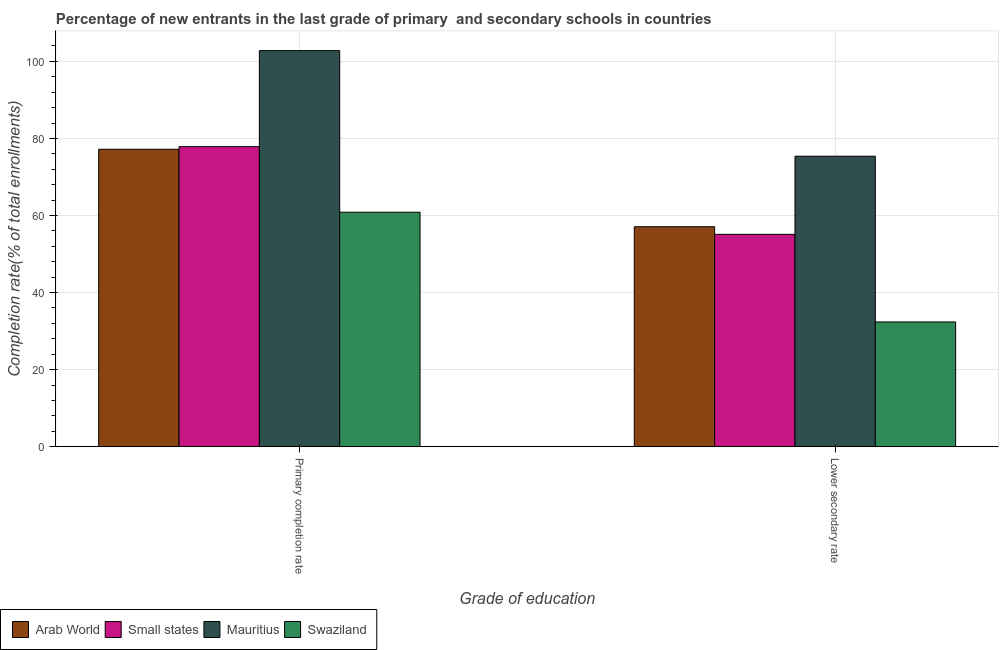How many different coloured bars are there?
Provide a short and direct response. 4. How many groups of bars are there?
Your answer should be very brief. 2. How many bars are there on the 2nd tick from the left?
Give a very brief answer. 4. What is the label of the 1st group of bars from the left?
Ensure brevity in your answer.  Primary completion rate. What is the completion rate in primary schools in Swaziland?
Give a very brief answer. 60.86. Across all countries, what is the maximum completion rate in primary schools?
Your answer should be very brief. 102.79. Across all countries, what is the minimum completion rate in primary schools?
Give a very brief answer. 60.86. In which country was the completion rate in primary schools maximum?
Your answer should be compact. Mauritius. In which country was the completion rate in primary schools minimum?
Provide a short and direct response. Swaziland. What is the total completion rate in secondary schools in the graph?
Ensure brevity in your answer.  219.97. What is the difference between the completion rate in primary schools in Mauritius and that in Small states?
Your response must be concise. 24.92. What is the difference between the completion rate in primary schools in Swaziland and the completion rate in secondary schools in Small states?
Ensure brevity in your answer.  5.75. What is the average completion rate in primary schools per country?
Provide a succinct answer. 79.68. What is the difference between the completion rate in secondary schools and completion rate in primary schools in Swaziland?
Make the answer very short. -28.48. In how many countries, is the completion rate in primary schools greater than 72 %?
Provide a succinct answer. 3. What is the ratio of the completion rate in secondary schools in Swaziland to that in Arab World?
Your response must be concise. 0.57. In how many countries, is the completion rate in secondary schools greater than the average completion rate in secondary schools taken over all countries?
Your answer should be very brief. 3. What does the 3rd bar from the left in Lower secondary rate represents?
Your response must be concise. Mauritius. What does the 2nd bar from the right in Lower secondary rate represents?
Provide a short and direct response. Mauritius. How many countries are there in the graph?
Offer a very short reply. 4. What is the difference between two consecutive major ticks on the Y-axis?
Your answer should be compact. 20. Are the values on the major ticks of Y-axis written in scientific E-notation?
Your answer should be compact. No. Does the graph contain grids?
Offer a terse response. Yes. Where does the legend appear in the graph?
Your response must be concise. Bottom left. What is the title of the graph?
Ensure brevity in your answer.  Percentage of new entrants in the last grade of primary  and secondary schools in countries. What is the label or title of the X-axis?
Offer a very short reply. Grade of education. What is the label or title of the Y-axis?
Your response must be concise. Completion rate(% of total enrollments). What is the Completion rate(% of total enrollments) in Arab World in Primary completion rate?
Provide a short and direct response. 77.19. What is the Completion rate(% of total enrollments) in Small states in Primary completion rate?
Your answer should be compact. 77.87. What is the Completion rate(% of total enrollments) of Mauritius in Primary completion rate?
Make the answer very short. 102.79. What is the Completion rate(% of total enrollments) in Swaziland in Primary completion rate?
Offer a very short reply. 60.86. What is the Completion rate(% of total enrollments) in Arab World in Lower secondary rate?
Give a very brief answer. 57.09. What is the Completion rate(% of total enrollments) in Small states in Lower secondary rate?
Provide a short and direct response. 55.11. What is the Completion rate(% of total enrollments) in Mauritius in Lower secondary rate?
Your answer should be very brief. 75.39. What is the Completion rate(% of total enrollments) in Swaziland in Lower secondary rate?
Make the answer very short. 32.38. Across all Grade of education, what is the maximum Completion rate(% of total enrollments) in Arab World?
Give a very brief answer. 77.19. Across all Grade of education, what is the maximum Completion rate(% of total enrollments) of Small states?
Provide a short and direct response. 77.87. Across all Grade of education, what is the maximum Completion rate(% of total enrollments) in Mauritius?
Offer a very short reply. 102.79. Across all Grade of education, what is the maximum Completion rate(% of total enrollments) of Swaziland?
Keep it short and to the point. 60.86. Across all Grade of education, what is the minimum Completion rate(% of total enrollments) in Arab World?
Provide a short and direct response. 57.09. Across all Grade of education, what is the minimum Completion rate(% of total enrollments) of Small states?
Your answer should be very brief. 55.11. Across all Grade of education, what is the minimum Completion rate(% of total enrollments) in Mauritius?
Give a very brief answer. 75.39. Across all Grade of education, what is the minimum Completion rate(% of total enrollments) in Swaziland?
Your answer should be very brief. 32.38. What is the total Completion rate(% of total enrollments) in Arab World in the graph?
Ensure brevity in your answer.  134.28. What is the total Completion rate(% of total enrollments) of Small states in the graph?
Your answer should be very brief. 132.99. What is the total Completion rate(% of total enrollments) of Mauritius in the graph?
Provide a short and direct response. 178.18. What is the total Completion rate(% of total enrollments) in Swaziland in the graph?
Your answer should be very brief. 93.24. What is the difference between the Completion rate(% of total enrollments) of Arab World in Primary completion rate and that in Lower secondary rate?
Provide a short and direct response. 20.11. What is the difference between the Completion rate(% of total enrollments) of Small states in Primary completion rate and that in Lower secondary rate?
Provide a short and direct response. 22.76. What is the difference between the Completion rate(% of total enrollments) of Mauritius in Primary completion rate and that in Lower secondary rate?
Provide a short and direct response. 27.4. What is the difference between the Completion rate(% of total enrollments) of Swaziland in Primary completion rate and that in Lower secondary rate?
Your response must be concise. 28.48. What is the difference between the Completion rate(% of total enrollments) of Arab World in Primary completion rate and the Completion rate(% of total enrollments) of Small states in Lower secondary rate?
Provide a succinct answer. 22.08. What is the difference between the Completion rate(% of total enrollments) of Arab World in Primary completion rate and the Completion rate(% of total enrollments) of Mauritius in Lower secondary rate?
Make the answer very short. 1.8. What is the difference between the Completion rate(% of total enrollments) of Arab World in Primary completion rate and the Completion rate(% of total enrollments) of Swaziland in Lower secondary rate?
Ensure brevity in your answer.  44.81. What is the difference between the Completion rate(% of total enrollments) in Small states in Primary completion rate and the Completion rate(% of total enrollments) in Mauritius in Lower secondary rate?
Make the answer very short. 2.48. What is the difference between the Completion rate(% of total enrollments) of Small states in Primary completion rate and the Completion rate(% of total enrollments) of Swaziland in Lower secondary rate?
Offer a terse response. 45.49. What is the difference between the Completion rate(% of total enrollments) of Mauritius in Primary completion rate and the Completion rate(% of total enrollments) of Swaziland in Lower secondary rate?
Make the answer very short. 70.41. What is the average Completion rate(% of total enrollments) in Arab World per Grade of education?
Offer a very short reply. 67.14. What is the average Completion rate(% of total enrollments) of Small states per Grade of education?
Offer a terse response. 66.49. What is the average Completion rate(% of total enrollments) in Mauritius per Grade of education?
Your answer should be very brief. 89.09. What is the average Completion rate(% of total enrollments) of Swaziland per Grade of education?
Offer a terse response. 46.62. What is the difference between the Completion rate(% of total enrollments) of Arab World and Completion rate(% of total enrollments) of Small states in Primary completion rate?
Offer a terse response. -0.68. What is the difference between the Completion rate(% of total enrollments) of Arab World and Completion rate(% of total enrollments) of Mauritius in Primary completion rate?
Make the answer very short. -25.6. What is the difference between the Completion rate(% of total enrollments) of Arab World and Completion rate(% of total enrollments) of Swaziland in Primary completion rate?
Provide a short and direct response. 16.33. What is the difference between the Completion rate(% of total enrollments) in Small states and Completion rate(% of total enrollments) in Mauritius in Primary completion rate?
Your answer should be compact. -24.92. What is the difference between the Completion rate(% of total enrollments) of Small states and Completion rate(% of total enrollments) of Swaziland in Primary completion rate?
Your response must be concise. 17.01. What is the difference between the Completion rate(% of total enrollments) in Mauritius and Completion rate(% of total enrollments) in Swaziland in Primary completion rate?
Keep it short and to the point. 41.93. What is the difference between the Completion rate(% of total enrollments) of Arab World and Completion rate(% of total enrollments) of Small states in Lower secondary rate?
Give a very brief answer. 1.97. What is the difference between the Completion rate(% of total enrollments) of Arab World and Completion rate(% of total enrollments) of Mauritius in Lower secondary rate?
Offer a terse response. -18.3. What is the difference between the Completion rate(% of total enrollments) of Arab World and Completion rate(% of total enrollments) of Swaziland in Lower secondary rate?
Keep it short and to the point. 24.7. What is the difference between the Completion rate(% of total enrollments) of Small states and Completion rate(% of total enrollments) of Mauritius in Lower secondary rate?
Your answer should be very brief. -20.28. What is the difference between the Completion rate(% of total enrollments) in Small states and Completion rate(% of total enrollments) in Swaziland in Lower secondary rate?
Provide a short and direct response. 22.73. What is the difference between the Completion rate(% of total enrollments) of Mauritius and Completion rate(% of total enrollments) of Swaziland in Lower secondary rate?
Make the answer very short. 43.01. What is the ratio of the Completion rate(% of total enrollments) of Arab World in Primary completion rate to that in Lower secondary rate?
Your answer should be compact. 1.35. What is the ratio of the Completion rate(% of total enrollments) of Small states in Primary completion rate to that in Lower secondary rate?
Make the answer very short. 1.41. What is the ratio of the Completion rate(% of total enrollments) in Mauritius in Primary completion rate to that in Lower secondary rate?
Make the answer very short. 1.36. What is the ratio of the Completion rate(% of total enrollments) of Swaziland in Primary completion rate to that in Lower secondary rate?
Provide a short and direct response. 1.88. What is the difference between the highest and the second highest Completion rate(% of total enrollments) of Arab World?
Your response must be concise. 20.11. What is the difference between the highest and the second highest Completion rate(% of total enrollments) of Small states?
Offer a terse response. 22.76. What is the difference between the highest and the second highest Completion rate(% of total enrollments) of Mauritius?
Give a very brief answer. 27.4. What is the difference between the highest and the second highest Completion rate(% of total enrollments) of Swaziland?
Give a very brief answer. 28.48. What is the difference between the highest and the lowest Completion rate(% of total enrollments) of Arab World?
Keep it short and to the point. 20.11. What is the difference between the highest and the lowest Completion rate(% of total enrollments) of Small states?
Provide a short and direct response. 22.76. What is the difference between the highest and the lowest Completion rate(% of total enrollments) of Mauritius?
Keep it short and to the point. 27.4. What is the difference between the highest and the lowest Completion rate(% of total enrollments) of Swaziland?
Make the answer very short. 28.48. 